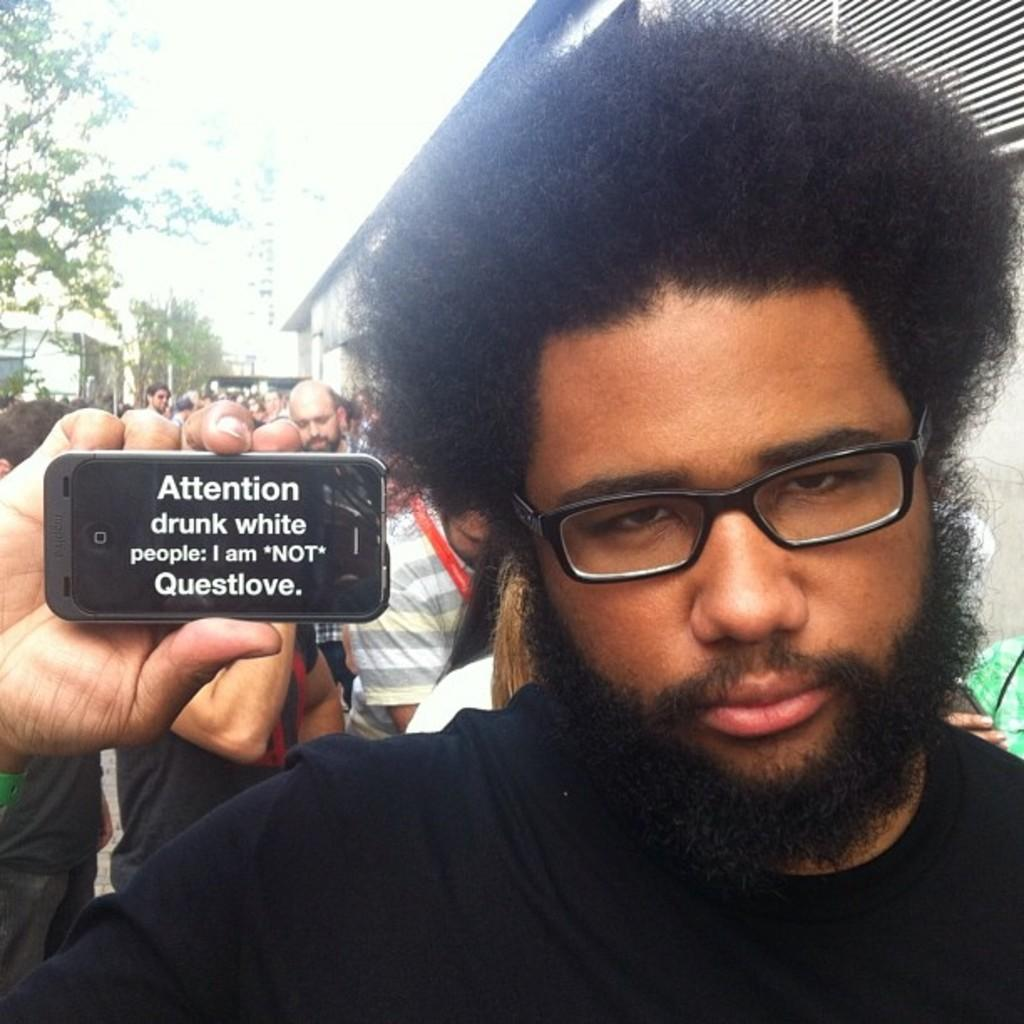Who is in the image? There is a person in the image. What is the person wearing? The person is wearing a black dress. What is the person holding in the image? The person is holding a mobile. What type of structure can be seen in the image? There is a tent in the image. What is visible at the top of the image? The sky is visible at the top of the image. What type of vegetation is present in the image? There are trees in the image. What type of exchange is taking place between the person and the trees in the image? There is no exchange taking place between the person and the trees in the image. The person is simply standing near the trees, and there is no interaction between them. 